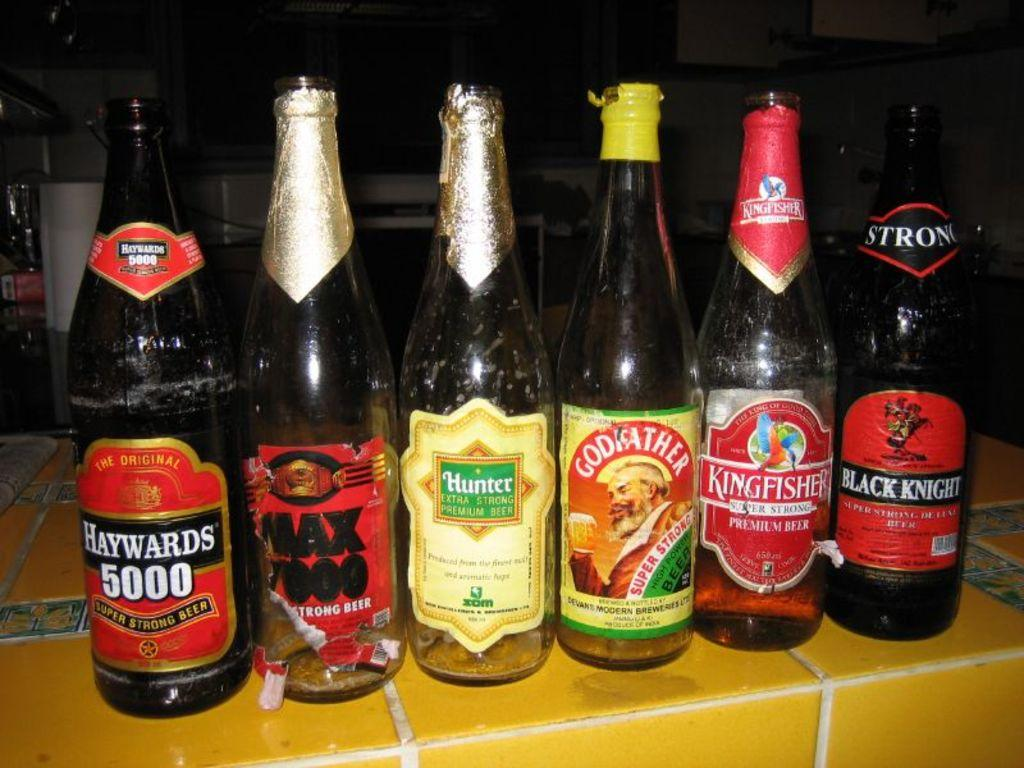<image>
Describe the image concisely. six bottle of ale, one of which is called Black Knight 